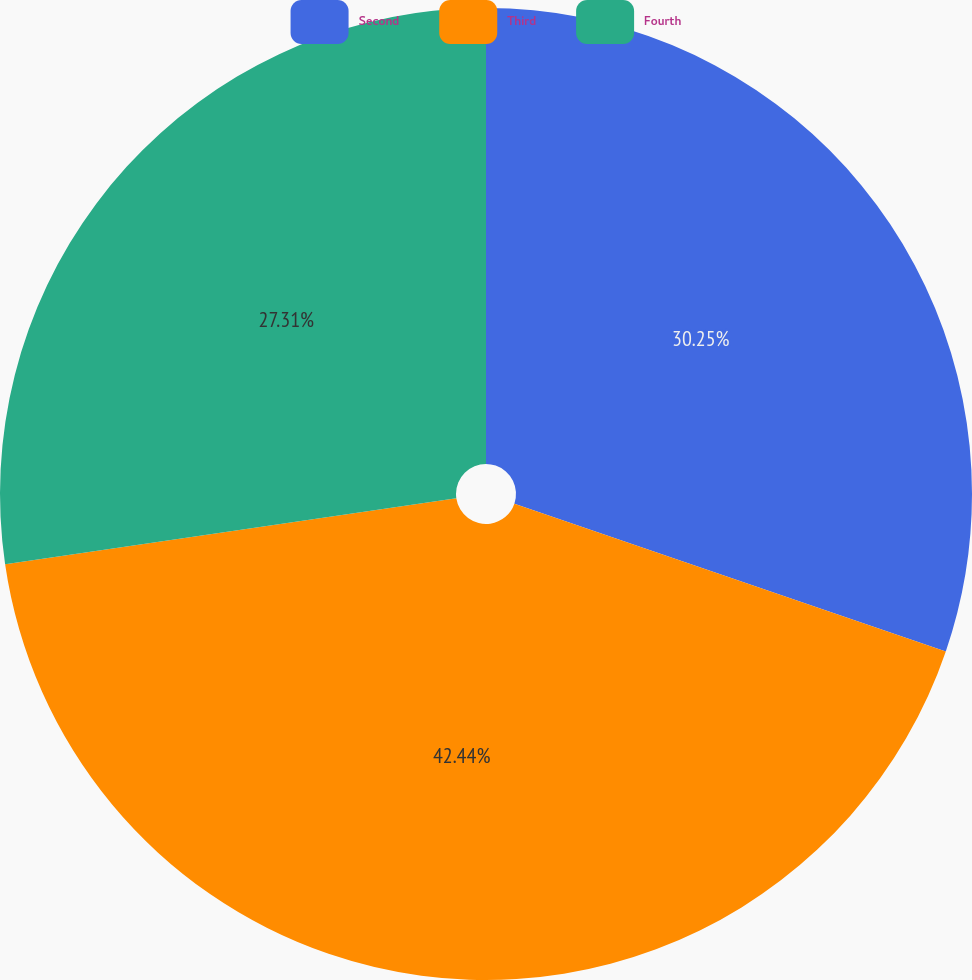<chart> <loc_0><loc_0><loc_500><loc_500><pie_chart><fcel>Second<fcel>Third<fcel>Fourth<nl><fcel>30.25%<fcel>42.44%<fcel>27.31%<nl></chart> 